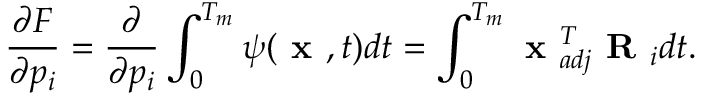<formula> <loc_0><loc_0><loc_500><loc_500>\frac { \partial F } { \partial p _ { i } } = \frac { \partial } { \partial p _ { i } } \int _ { 0 } ^ { T _ { m } } \psi ( x , t ) d t = \int _ { 0 } ^ { T _ { m } } x _ { a d j } ^ { T } R _ { i } d t .</formula> 